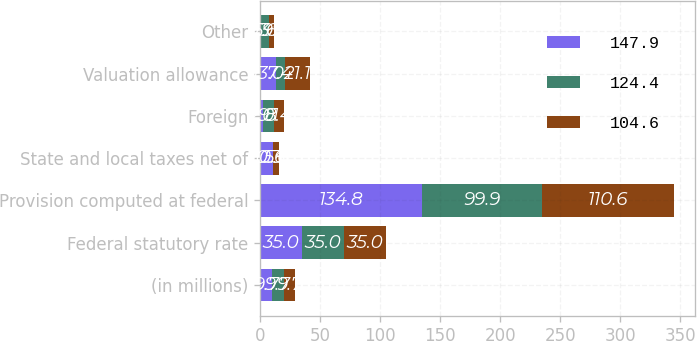Convert chart. <chart><loc_0><loc_0><loc_500><loc_500><stacked_bar_chart><ecel><fcel>(in millions)<fcel>Federal statutory rate<fcel>Provision computed at federal<fcel>State and local taxes net of<fcel>Foreign<fcel>Valuation allowance<fcel>Other<nl><fcel>147.9<fcel>9.7<fcel>35<fcel>134.8<fcel>10.3<fcel>2<fcel>13<fcel>0.9<nl><fcel>124.4<fcel>9.7<fcel>35<fcel>99.9<fcel>0.6<fcel>9.1<fcel>7.4<fcel>6.6<nl><fcel>104.6<fcel>9.7<fcel>35<fcel>110.6<fcel>5<fcel>8.4<fcel>21.1<fcel>3.9<nl></chart> 